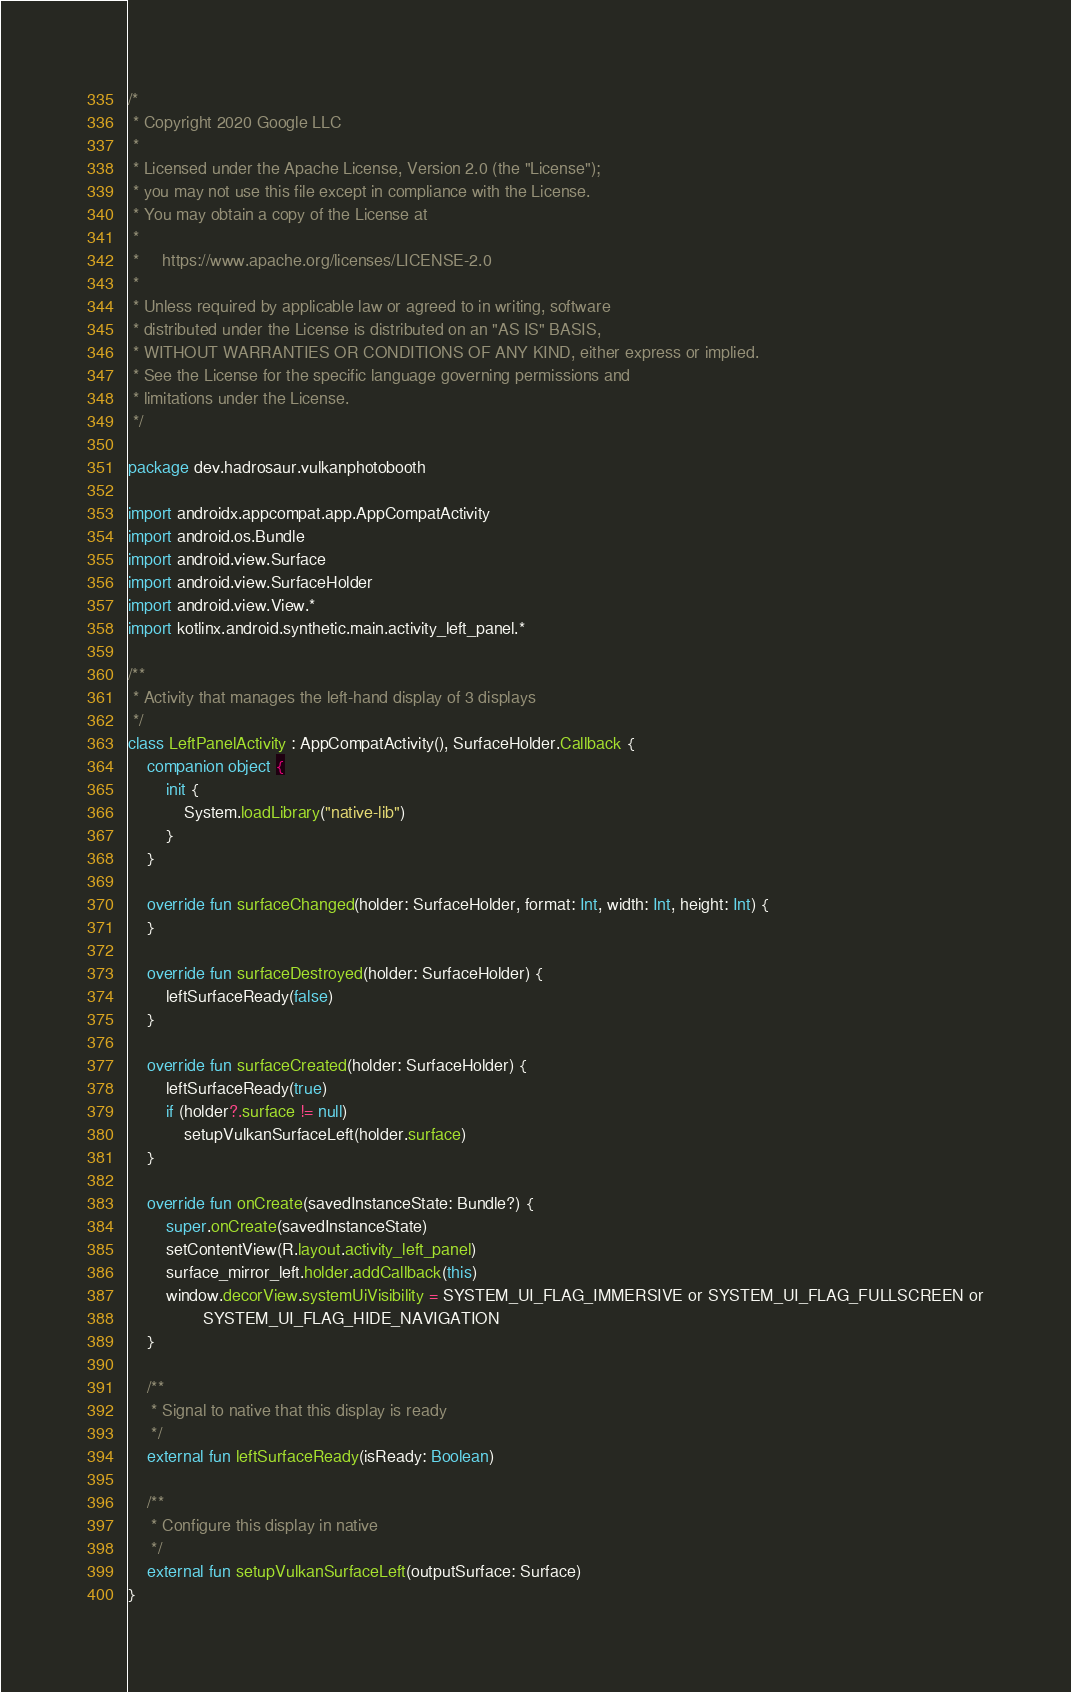<code> <loc_0><loc_0><loc_500><loc_500><_Kotlin_>/*
 * Copyright 2020 Google LLC
 *
 * Licensed under the Apache License, Version 2.0 (the "License");
 * you may not use this file except in compliance with the License.
 * You may obtain a copy of the License at
 *
 *     https://www.apache.org/licenses/LICENSE-2.0
 *
 * Unless required by applicable law or agreed to in writing, software
 * distributed under the License is distributed on an "AS IS" BASIS,
 * WITHOUT WARRANTIES OR CONDITIONS OF ANY KIND, either express or implied.
 * See the License for the specific language governing permissions and
 * limitations under the License.
 */

package dev.hadrosaur.vulkanphotobooth

import androidx.appcompat.app.AppCompatActivity
import android.os.Bundle
import android.view.Surface
import android.view.SurfaceHolder
import android.view.View.*
import kotlinx.android.synthetic.main.activity_left_panel.*

/**
 * Activity that manages the left-hand display of 3 displays
 */
class LeftPanelActivity : AppCompatActivity(), SurfaceHolder.Callback {
    companion object {
        init {
            System.loadLibrary("native-lib")
        }
    }

    override fun surfaceChanged(holder: SurfaceHolder, format: Int, width: Int, height: Int) {
    }

    override fun surfaceDestroyed(holder: SurfaceHolder) {
        leftSurfaceReady(false)
    }

    override fun surfaceCreated(holder: SurfaceHolder) {
        leftSurfaceReady(true)
        if (holder?.surface != null)
            setupVulkanSurfaceLeft(holder.surface)
    }

    override fun onCreate(savedInstanceState: Bundle?) {
        super.onCreate(savedInstanceState)
        setContentView(R.layout.activity_left_panel)
        surface_mirror_left.holder.addCallback(this)
        window.decorView.systemUiVisibility = SYSTEM_UI_FLAG_IMMERSIVE or SYSTEM_UI_FLAG_FULLSCREEN or
                SYSTEM_UI_FLAG_HIDE_NAVIGATION
    }

    /**
     * Signal to native that this display is ready
     */
    external fun leftSurfaceReady(isReady: Boolean)

    /**
     * Configure this display in native
     */
    external fun setupVulkanSurfaceLeft(outputSurface: Surface)
}
</code> 